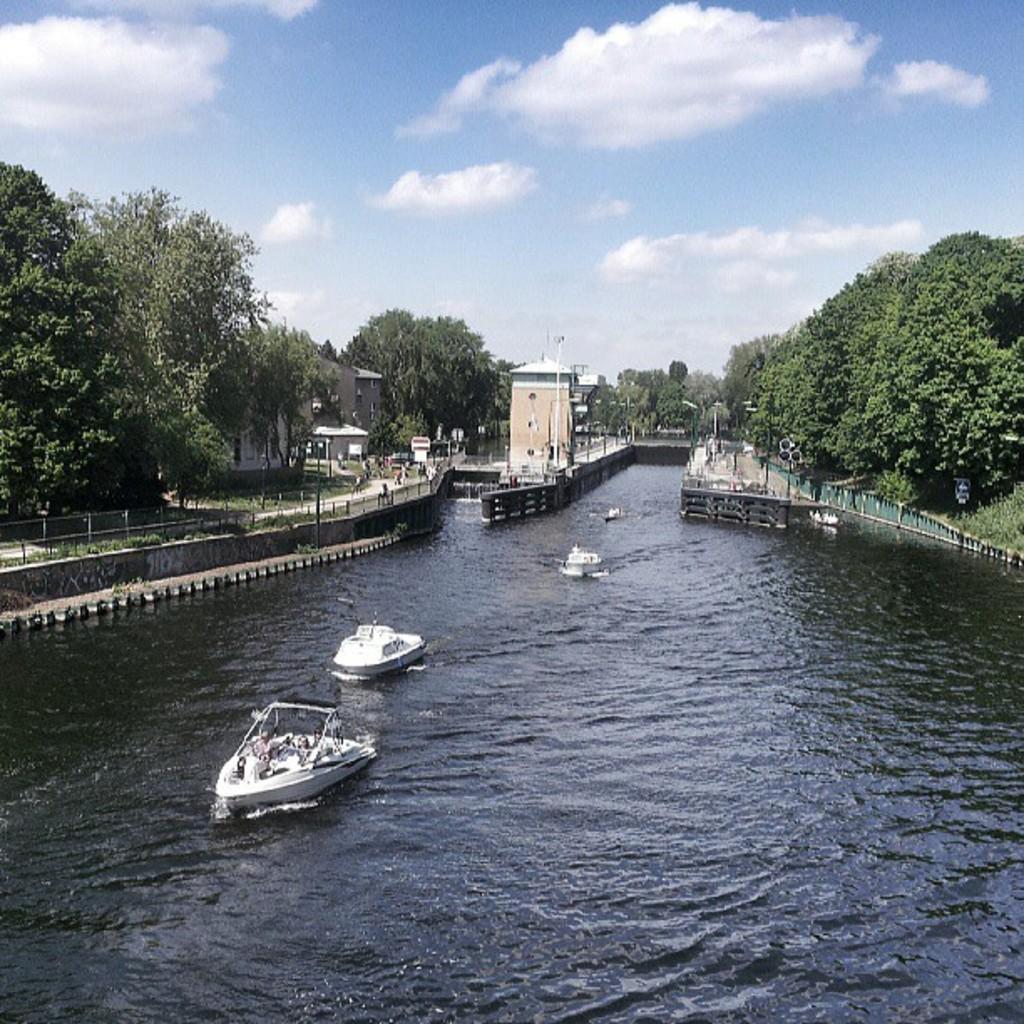Describe this image in one or two sentences. In this picture I can see boats on the water, there are buildings, there are trees, and in the background there is the sky. 